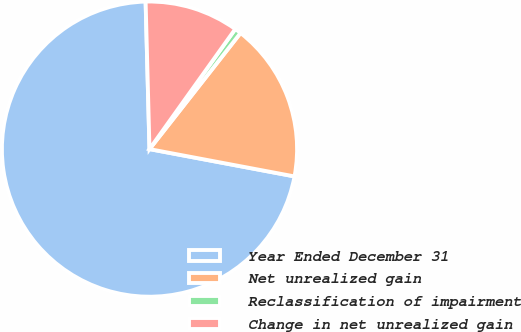Convert chart. <chart><loc_0><loc_0><loc_500><loc_500><pie_chart><fcel>Year Ended December 31<fcel>Net unrealized gain<fcel>Reclassification of impairment<fcel>Change in net unrealized gain<nl><fcel>71.62%<fcel>17.38%<fcel>0.71%<fcel>10.29%<nl></chart> 